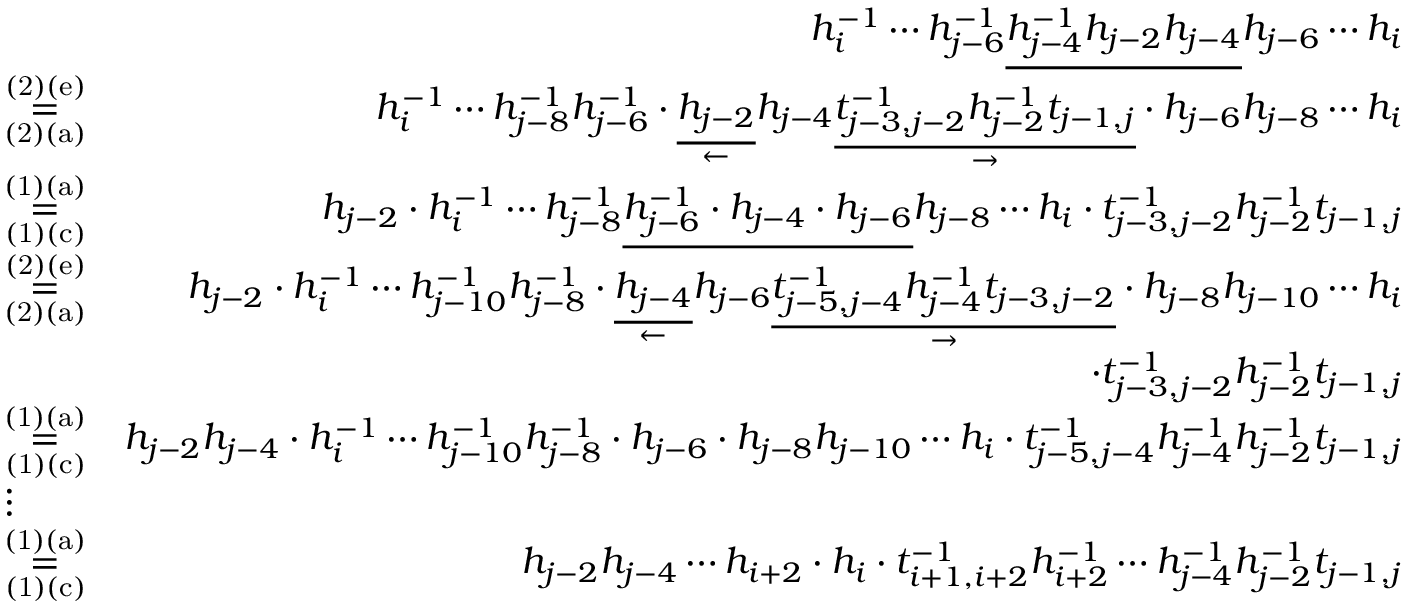Convert formula to latex. <formula><loc_0><loc_0><loc_500><loc_500>\begin{array} { r l r } & { h _ { i } ^ { - 1 } \cdots h _ { j - 6 } ^ { - 1 } \underline { { h _ { j - 4 } ^ { - 1 } h _ { j - 2 } h _ { j - 4 } } } h _ { j - 6 } \cdots h _ { i } } \\ & { \overset { ( 2 ) ( e ) } { \underset { ( 2 ) ( a ) } { = } } } & { h _ { i } ^ { - 1 } \cdots h _ { j - 8 } ^ { - 1 } h _ { j - 6 } ^ { - 1 } \cdot \underset { \leftarrow } { \underline { { h _ { j - 2 } } } } h _ { j - 4 } \underset { \rightarrow } { \underline { { t _ { j - 3 , j - 2 } ^ { - 1 } h _ { j - 2 } ^ { - 1 } t _ { j - 1 , j } } } } \cdot h _ { j - 6 } h _ { j - 8 } \cdots h _ { i } } \\ & { \overset { ( 1 ) ( a ) } { \underset { ( 1 ) ( c ) } { = } } } & { h _ { j - 2 } \cdot h _ { i } ^ { - 1 } \cdots h _ { j - 8 } ^ { - 1 } \underline { { h _ { j - 6 } ^ { - 1 } \cdot h _ { j - 4 } \cdot h _ { j - 6 } } } h _ { j - 8 } \cdots h _ { i } \cdot t _ { j - 3 , j - 2 } ^ { - 1 } h _ { j - 2 } ^ { - 1 } t _ { j - 1 , j } } \\ & { \overset { ( 2 ) ( e ) } { \underset { ( 2 ) ( a ) } { = } } } & { h _ { j - 2 } \cdot h _ { i } ^ { - 1 } \cdots h _ { j - 1 0 } ^ { - 1 } h _ { j - 8 } ^ { - 1 } \cdot \underset { \leftarrow } { \underline { { h _ { j - 4 } } } } h _ { j - 6 } \underset { \rightarrow } { \underline { { t _ { j - 5 , j - 4 } ^ { - 1 } h _ { j - 4 } ^ { - 1 } t _ { j - 3 , j - 2 } } } } \cdot h _ { j - 8 } h _ { j - 1 0 } \cdots h _ { i } } \\ & { \cdot t _ { j - 3 , j - 2 } ^ { - 1 } h _ { j - 2 } ^ { - 1 } t _ { j - 1 , j } } \\ & { \overset { ( 1 ) ( a ) } { \underset { ( 1 ) ( c ) } { = } } } & { h _ { j - 2 } h _ { j - 4 } \cdot h _ { i } ^ { - 1 } \cdots h _ { j - 1 0 } ^ { - 1 } h _ { j - 8 } ^ { - 1 } \cdot h _ { j - 6 } \cdot h _ { j - 8 } h _ { j - 1 0 } \cdots h _ { i } \cdot t _ { j - 5 , j - 4 } ^ { - 1 } h _ { j - 4 } ^ { - 1 } h _ { j - 2 } ^ { - 1 } t _ { j - 1 , j } } \\ & { \vdots } & \\ & { \overset { ( 1 ) ( a ) } { \underset { ( 1 ) ( c ) } { = } } } & { h _ { j - 2 } h _ { j - 4 } \cdots h _ { i + 2 } \cdot h _ { i } \cdot t _ { i + 1 , i + 2 } ^ { - 1 } h _ { i + 2 } ^ { - 1 } \cdots h _ { j - 4 } ^ { - 1 } h _ { j - 2 } ^ { - 1 } t _ { j - 1 , j } } \end{array}</formula> 